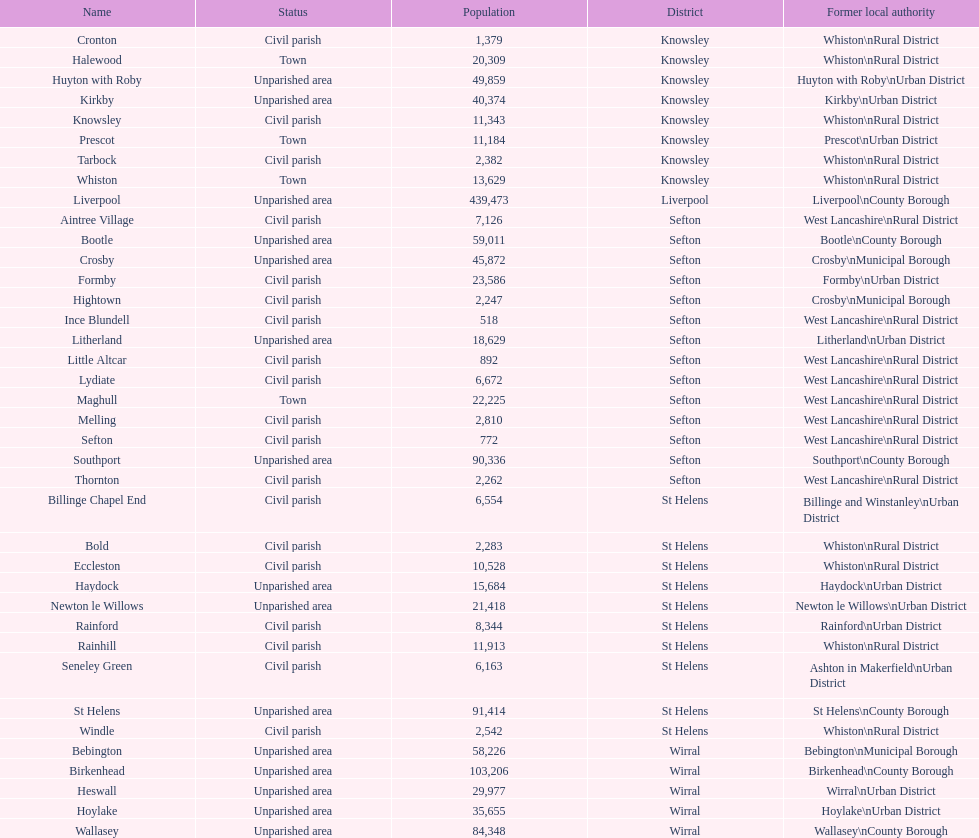What is the largest area in terms of population? Liverpool. 